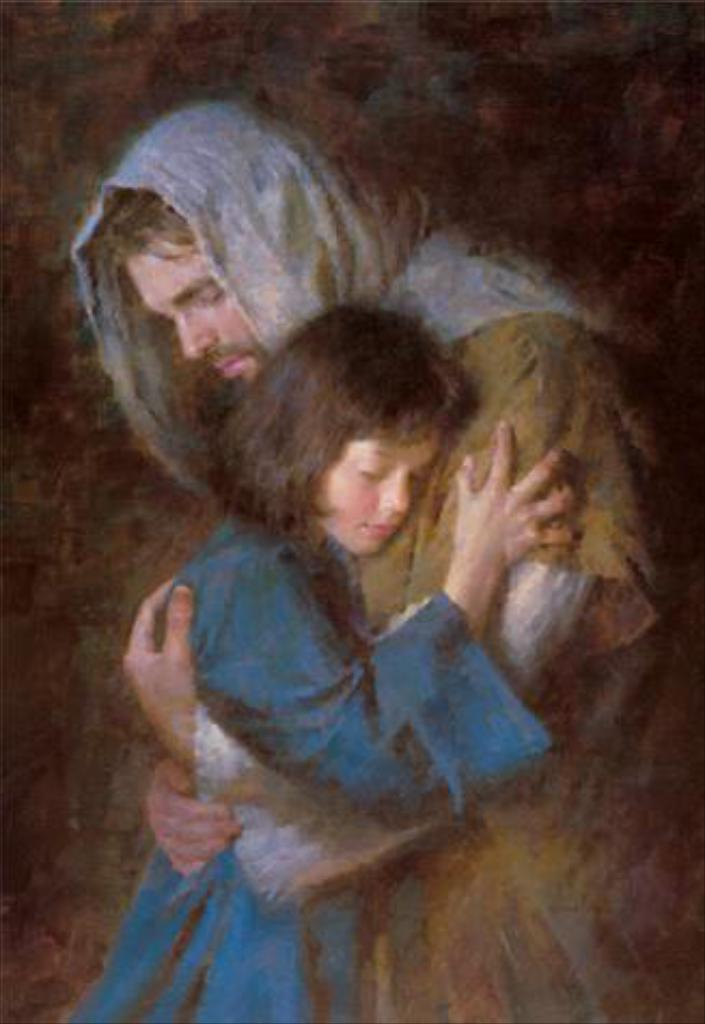What is the main subject of the image? There is a painting in the image. What is depicted in the painting? The painting depicts a man and a girl hugging each other. How many books are stacked on the floor in the image? There are no books visible in the image; it only features a painting of a man and a girl hugging each other. 